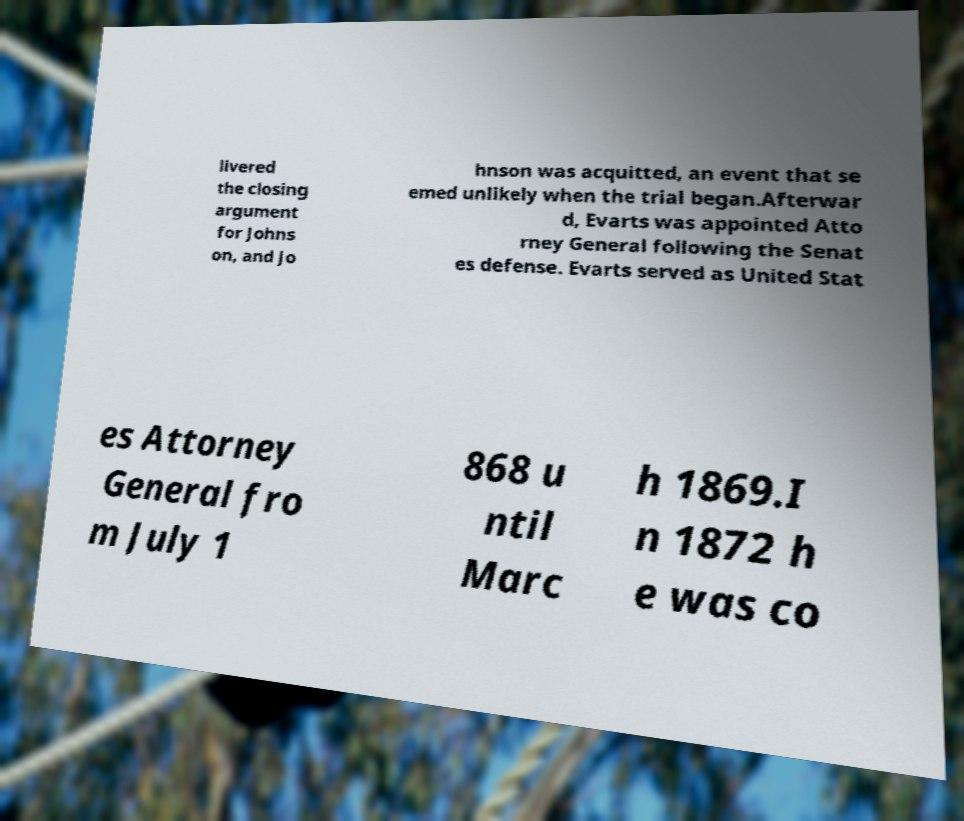For documentation purposes, I need the text within this image transcribed. Could you provide that? livered the closing argument for Johns on, and Jo hnson was acquitted, an event that se emed unlikely when the trial began.Afterwar d, Evarts was appointed Atto rney General following the Senat es defense. Evarts served as United Stat es Attorney General fro m July 1 868 u ntil Marc h 1869.I n 1872 h e was co 